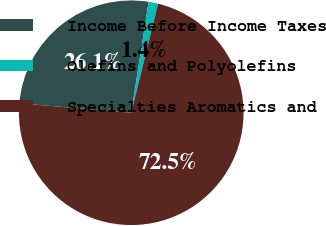<chart> <loc_0><loc_0><loc_500><loc_500><pie_chart><fcel>Income Before Income Taxes<fcel>Olefins and Polyolefins<fcel>Specialties Aromatics and<nl><fcel>26.14%<fcel>1.37%<fcel>72.49%<nl></chart> 